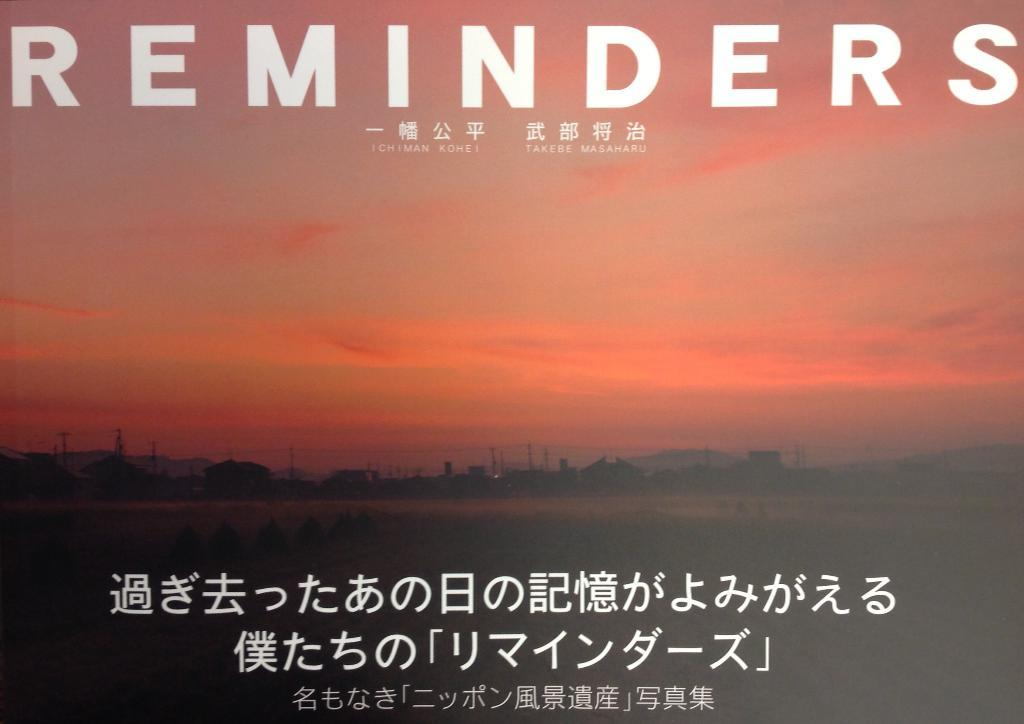<image>
Offer a succinct explanation of the picture presented. A poster reminding people of things in front of a sun set. 